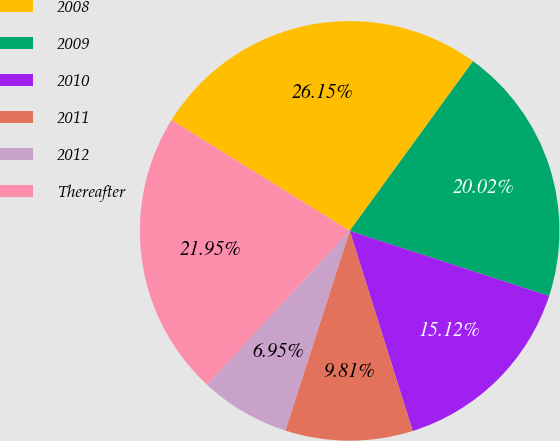Convert chart. <chart><loc_0><loc_0><loc_500><loc_500><pie_chart><fcel>2008<fcel>2009<fcel>2010<fcel>2011<fcel>2012<fcel>Thereafter<nl><fcel>26.15%<fcel>20.02%<fcel>15.12%<fcel>9.81%<fcel>6.95%<fcel>21.95%<nl></chart> 